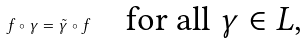<formula> <loc_0><loc_0><loc_500><loc_500>f \circ \gamma = \tilde { \gamma } \circ f \quad \text {for all $\gamma\in L$,}</formula> 